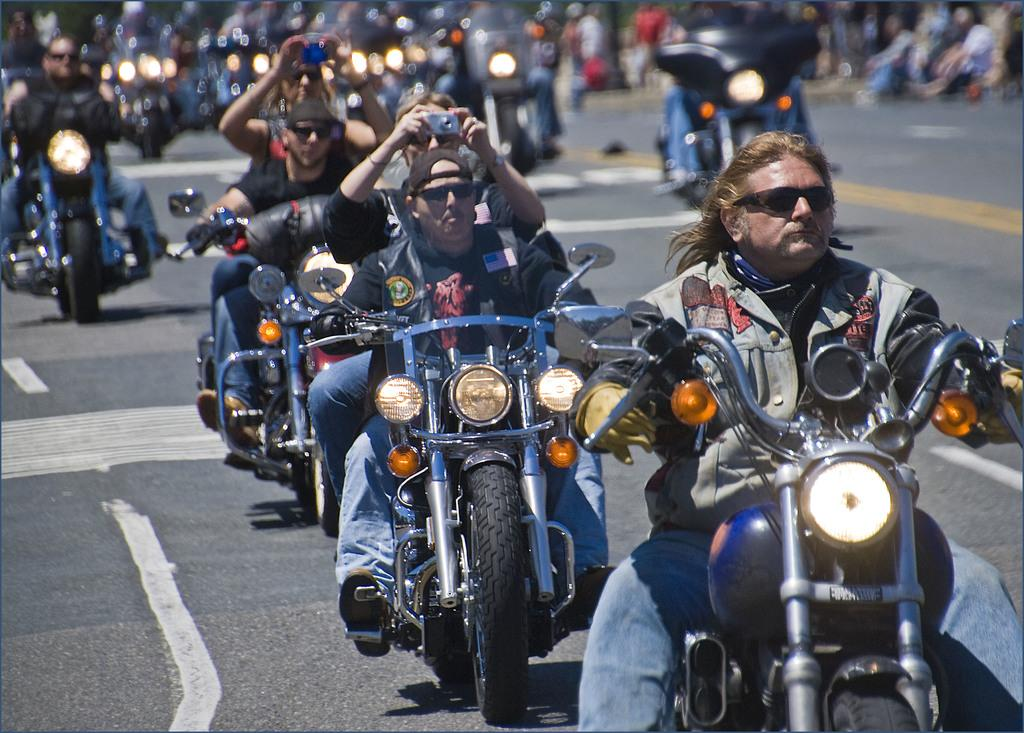What is happening in the image? There is a group of men riding motorcycles in the image. Where are the men riding their motorcycles? The motorcycles are on a road. How many motorcycles can be seen in the image? Since there is a group of men, there are at least as many motorcycles as there are men. Can you see any fangs on the motorcycles in the image? There are no fangs present on the motorcycles in the image. How do the men maintain their balance while riding the motorcycles? The image does not show the men's balance or any specific techniques they might be using to maintain it. 